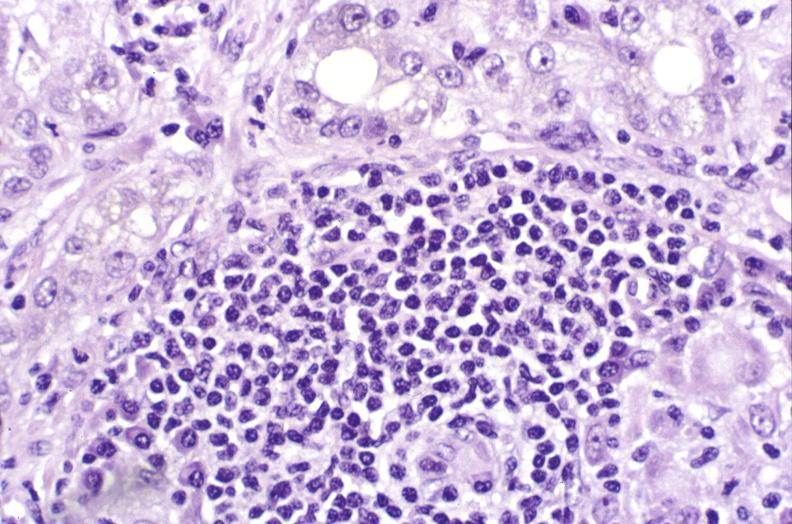what does this image show?
Answer the question using a single word or phrase. Primary biliary cirrhosis 